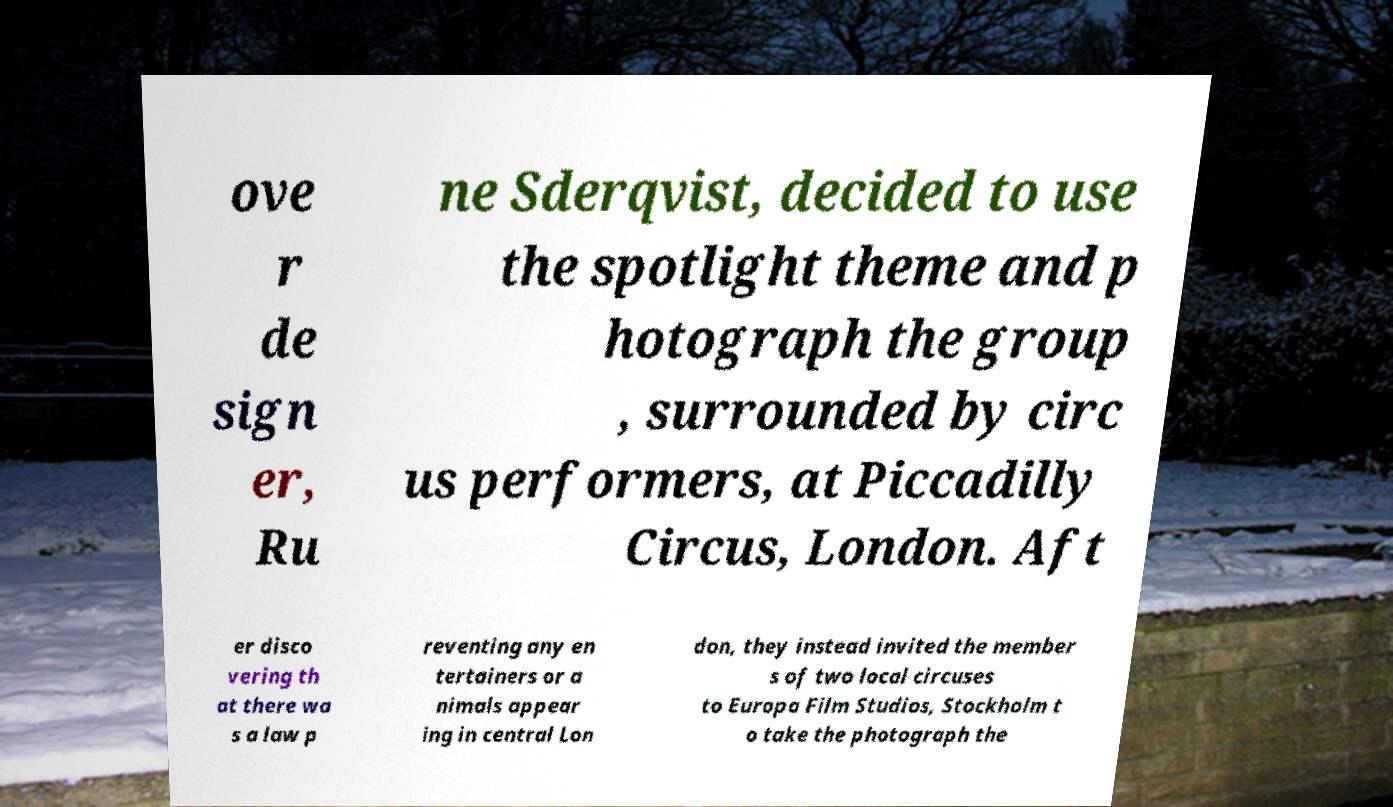Please read and relay the text visible in this image. What does it say? ove r de sign er, Ru ne Sderqvist, decided to use the spotlight theme and p hotograph the group , surrounded by circ us performers, at Piccadilly Circus, London. Aft er disco vering th at there wa s a law p reventing any en tertainers or a nimals appear ing in central Lon don, they instead invited the member s of two local circuses to Europa Film Studios, Stockholm t o take the photograph the 